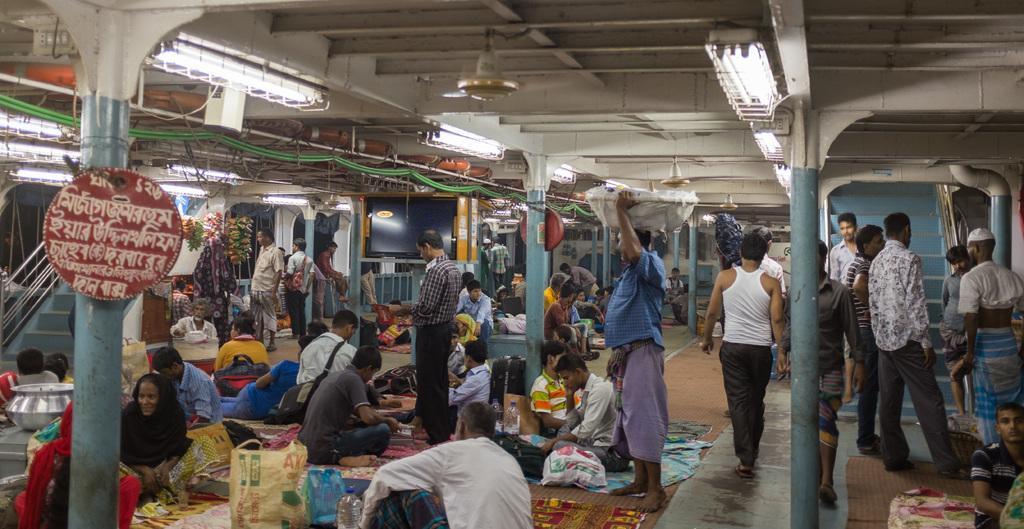How would you summarize this image in a sentence or two? This picture describes about group of people, few are seated and few are standing, in front of them we can see baggage and other things, in the background we can see few metal rods, cables, lights and fans, on the left side of the image we can find some text on the board. 